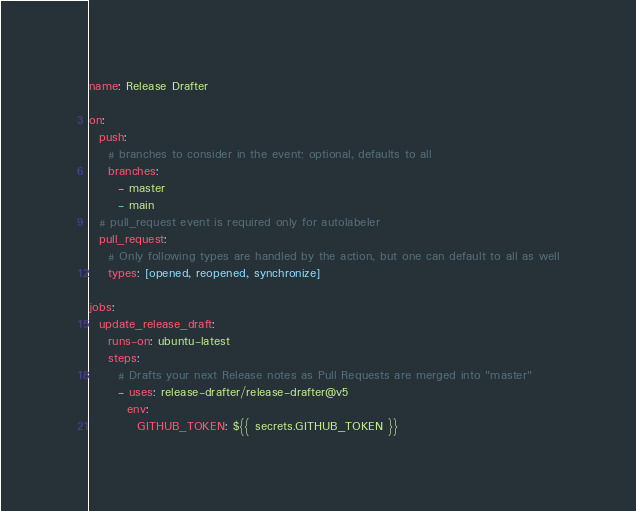<code> <loc_0><loc_0><loc_500><loc_500><_YAML_>name: Release Drafter

on:
  push:
    # branches to consider in the event; optional, defaults to all
    branches:
      - master
      - main
  # pull_request event is required only for autolabeler
  pull_request:
    # Only following types are handled by the action, but one can default to all as well
    types: [opened, reopened, synchronize]

jobs:
  update_release_draft:
    runs-on: ubuntu-latest
    steps:
      # Drafts your next Release notes as Pull Requests are merged into "master"
      - uses: release-drafter/release-drafter@v5
        env:
          GITHUB_TOKEN: ${{ secrets.GITHUB_TOKEN }}
</code> 